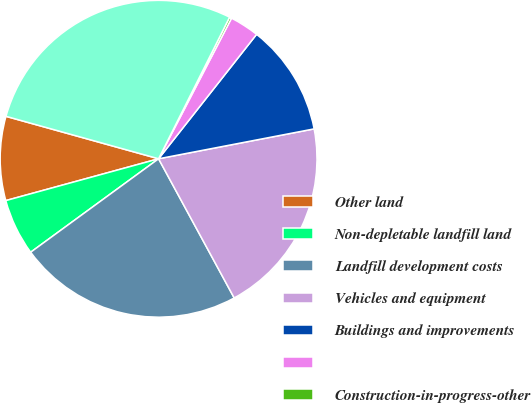Convert chart to OTSL. <chart><loc_0><loc_0><loc_500><loc_500><pie_chart><fcel>Other land<fcel>Non-depletable landfill land<fcel>Landfill development costs<fcel>Vehicles and equipment<fcel>Buildings and improvements<fcel>Unnamed: 5<fcel>Construction-in-progress-other<fcel>Property and equipment net<nl><fcel>8.57%<fcel>5.79%<fcel>22.88%<fcel>20.1%<fcel>11.36%<fcel>3.0%<fcel>0.22%<fcel>28.08%<nl></chart> 